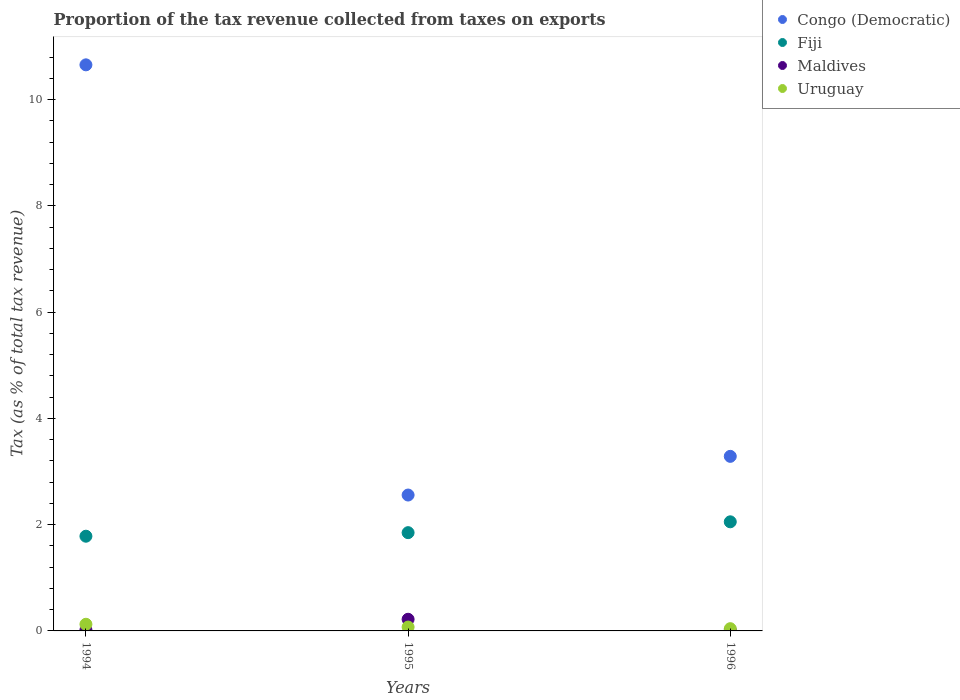How many different coloured dotlines are there?
Offer a very short reply. 4. What is the proportion of the tax revenue collected in Fiji in 1996?
Offer a terse response. 2.05. Across all years, what is the maximum proportion of the tax revenue collected in Maldives?
Offer a terse response. 0.22. Across all years, what is the minimum proportion of the tax revenue collected in Uruguay?
Keep it short and to the point. 0.04. What is the total proportion of the tax revenue collected in Maldives in the graph?
Provide a succinct answer. 0.25. What is the difference between the proportion of the tax revenue collected in Maldives in 1995 and that in 1996?
Provide a short and direct response. 0.21. What is the difference between the proportion of the tax revenue collected in Fiji in 1994 and the proportion of the tax revenue collected in Congo (Democratic) in 1996?
Your response must be concise. -1.5. What is the average proportion of the tax revenue collected in Uruguay per year?
Provide a succinct answer. 0.08. In the year 1995, what is the difference between the proportion of the tax revenue collected in Maldives and proportion of the tax revenue collected in Fiji?
Provide a succinct answer. -1.63. In how many years, is the proportion of the tax revenue collected in Fiji greater than 4.8 %?
Offer a very short reply. 0. What is the ratio of the proportion of the tax revenue collected in Congo (Democratic) in 1995 to that in 1996?
Ensure brevity in your answer.  0.78. Is the proportion of the tax revenue collected in Maldives in 1995 less than that in 1996?
Offer a very short reply. No. Is the difference between the proportion of the tax revenue collected in Maldives in 1995 and 1996 greater than the difference between the proportion of the tax revenue collected in Fiji in 1995 and 1996?
Your answer should be compact. Yes. What is the difference between the highest and the second highest proportion of the tax revenue collected in Congo (Democratic)?
Your answer should be very brief. 7.37. What is the difference between the highest and the lowest proportion of the tax revenue collected in Congo (Democratic)?
Give a very brief answer. 8.1. In how many years, is the proportion of the tax revenue collected in Fiji greater than the average proportion of the tax revenue collected in Fiji taken over all years?
Offer a very short reply. 1. Is it the case that in every year, the sum of the proportion of the tax revenue collected in Uruguay and proportion of the tax revenue collected in Fiji  is greater than the sum of proportion of the tax revenue collected in Congo (Democratic) and proportion of the tax revenue collected in Maldives?
Make the answer very short. No. Is the proportion of the tax revenue collected in Maldives strictly less than the proportion of the tax revenue collected in Uruguay over the years?
Your response must be concise. No. How many dotlines are there?
Your response must be concise. 4. Does the graph contain grids?
Offer a terse response. No. How many legend labels are there?
Provide a short and direct response. 4. What is the title of the graph?
Your answer should be compact. Proportion of the tax revenue collected from taxes on exports. Does "Albania" appear as one of the legend labels in the graph?
Offer a very short reply. No. What is the label or title of the Y-axis?
Your answer should be compact. Tax (as % of total tax revenue). What is the Tax (as % of total tax revenue) in Congo (Democratic) in 1994?
Ensure brevity in your answer.  10.65. What is the Tax (as % of total tax revenue) in Fiji in 1994?
Make the answer very short. 1.78. What is the Tax (as % of total tax revenue) of Maldives in 1994?
Your response must be concise. 0.02. What is the Tax (as % of total tax revenue) in Uruguay in 1994?
Your answer should be compact. 0.13. What is the Tax (as % of total tax revenue) of Congo (Democratic) in 1995?
Your answer should be compact. 2.56. What is the Tax (as % of total tax revenue) of Fiji in 1995?
Ensure brevity in your answer.  1.85. What is the Tax (as % of total tax revenue) of Maldives in 1995?
Give a very brief answer. 0.22. What is the Tax (as % of total tax revenue) in Uruguay in 1995?
Ensure brevity in your answer.  0.07. What is the Tax (as % of total tax revenue) in Congo (Democratic) in 1996?
Offer a terse response. 3.29. What is the Tax (as % of total tax revenue) in Fiji in 1996?
Your response must be concise. 2.05. What is the Tax (as % of total tax revenue) of Maldives in 1996?
Your response must be concise. 0.01. What is the Tax (as % of total tax revenue) of Uruguay in 1996?
Your response must be concise. 0.04. Across all years, what is the maximum Tax (as % of total tax revenue) in Congo (Democratic)?
Your answer should be very brief. 10.65. Across all years, what is the maximum Tax (as % of total tax revenue) of Fiji?
Your response must be concise. 2.05. Across all years, what is the maximum Tax (as % of total tax revenue) in Maldives?
Make the answer very short. 0.22. Across all years, what is the maximum Tax (as % of total tax revenue) of Uruguay?
Ensure brevity in your answer.  0.13. Across all years, what is the minimum Tax (as % of total tax revenue) in Congo (Democratic)?
Make the answer very short. 2.56. Across all years, what is the minimum Tax (as % of total tax revenue) in Fiji?
Keep it short and to the point. 1.78. Across all years, what is the minimum Tax (as % of total tax revenue) of Maldives?
Make the answer very short. 0.01. Across all years, what is the minimum Tax (as % of total tax revenue) in Uruguay?
Your answer should be very brief. 0.04. What is the total Tax (as % of total tax revenue) of Congo (Democratic) in the graph?
Make the answer very short. 16.5. What is the total Tax (as % of total tax revenue) in Fiji in the graph?
Give a very brief answer. 5.69. What is the total Tax (as % of total tax revenue) of Maldives in the graph?
Provide a short and direct response. 0.25. What is the total Tax (as % of total tax revenue) of Uruguay in the graph?
Offer a terse response. 0.24. What is the difference between the Tax (as % of total tax revenue) of Congo (Democratic) in 1994 and that in 1995?
Your answer should be compact. 8.1. What is the difference between the Tax (as % of total tax revenue) in Fiji in 1994 and that in 1995?
Your answer should be very brief. -0.07. What is the difference between the Tax (as % of total tax revenue) in Maldives in 1994 and that in 1995?
Offer a terse response. -0.2. What is the difference between the Tax (as % of total tax revenue) of Uruguay in 1994 and that in 1995?
Provide a succinct answer. 0.05. What is the difference between the Tax (as % of total tax revenue) of Congo (Democratic) in 1994 and that in 1996?
Make the answer very short. 7.37. What is the difference between the Tax (as % of total tax revenue) of Fiji in 1994 and that in 1996?
Make the answer very short. -0.27. What is the difference between the Tax (as % of total tax revenue) of Maldives in 1994 and that in 1996?
Your answer should be very brief. 0. What is the difference between the Tax (as % of total tax revenue) in Uruguay in 1994 and that in 1996?
Your answer should be very brief. 0.08. What is the difference between the Tax (as % of total tax revenue) in Congo (Democratic) in 1995 and that in 1996?
Make the answer very short. -0.73. What is the difference between the Tax (as % of total tax revenue) in Fiji in 1995 and that in 1996?
Your answer should be compact. -0.2. What is the difference between the Tax (as % of total tax revenue) in Maldives in 1995 and that in 1996?
Offer a very short reply. 0.21. What is the difference between the Tax (as % of total tax revenue) of Uruguay in 1995 and that in 1996?
Offer a very short reply. 0.03. What is the difference between the Tax (as % of total tax revenue) of Congo (Democratic) in 1994 and the Tax (as % of total tax revenue) of Fiji in 1995?
Offer a very short reply. 8.8. What is the difference between the Tax (as % of total tax revenue) of Congo (Democratic) in 1994 and the Tax (as % of total tax revenue) of Maldives in 1995?
Provide a short and direct response. 10.44. What is the difference between the Tax (as % of total tax revenue) of Congo (Democratic) in 1994 and the Tax (as % of total tax revenue) of Uruguay in 1995?
Your answer should be very brief. 10.58. What is the difference between the Tax (as % of total tax revenue) in Fiji in 1994 and the Tax (as % of total tax revenue) in Maldives in 1995?
Ensure brevity in your answer.  1.56. What is the difference between the Tax (as % of total tax revenue) of Fiji in 1994 and the Tax (as % of total tax revenue) of Uruguay in 1995?
Make the answer very short. 1.71. What is the difference between the Tax (as % of total tax revenue) of Maldives in 1994 and the Tax (as % of total tax revenue) of Uruguay in 1995?
Make the answer very short. -0.05. What is the difference between the Tax (as % of total tax revenue) of Congo (Democratic) in 1994 and the Tax (as % of total tax revenue) of Fiji in 1996?
Make the answer very short. 8.6. What is the difference between the Tax (as % of total tax revenue) of Congo (Democratic) in 1994 and the Tax (as % of total tax revenue) of Maldives in 1996?
Offer a very short reply. 10.64. What is the difference between the Tax (as % of total tax revenue) in Congo (Democratic) in 1994 and the Tax (as % of total tax revenue) in Uruguay in 1996?
Keep it short and to the point. 10.61. What is the difference between the Tax (as % of total tax revenue) in Fiji in 1994 and the Tax (as % of total tax revenue) in Maldives in 1996?
Your answer should be very brief. 1.77. What is the difference between the Tax (as % of total tax revenue) of Fiji in 1994 and the Tax (as % of total tax revenue) of Uruguay in 1996?
Make the answer very short. 1.74. What is the difference between the Tax (as % of total tax revenue) of Maldives in 1994 and the Tax (as % of total tax revenue) of Uruguay in 1996?
Offer a terse response. -0.02. What is the difference between the Tax (as % of total tax revenue) of Congo (Democratic) in 1995 and the Tax (as % of total tax revenue) of Fiji in 1996?
Give a very brief answer. 0.5. What is the difference between the Tax (as % of total tax revenue) of Congo (Democratic) in 1995 and the Tax (as % of total tax revenue) of Maldives in 1996?
Your answer should be compact. 2.54. What is the difference between the Tax (as % of total tax revenue) of Congo (Democratic) in 1995 and the Tax (as % of total tax revenue) of Uruguay in 1996?
Provide a short and direct response. 2.52. What is the difference between the Tax (as % of total tax revenue) of Fiji in 1995 and the Tax (as % of total tax revenue) of Maldives in 1996?
Your answer should be very brief. 1.84. What is the difference between the Tax (as % of total tax revenue) in Fiji in 1995 and the Tax (as % of total tax revenue) in Uruguay in 1996?
Your response must be concise. 1.81. What is the difference between the Tax (as % of total tax revenue) in Maldives in 1995 and the Tax (as % of total tax revenue) in Uruguay in 1996?
Provide a succinct answer. 0.18. What is the average Tax (as % of total tax revenue) of Congo (Democratic) per year?
Provide a short and direct response. 5.5. What is the average Tax (as % of total tax revenue) in Fiji per year?
Provide a short and direct response. 1.9. What is the average Tax (as % of total tax revenue) in Maldives per year?
Keep it short and to the point. 0.08. In the year 1994, what is the difference between the Tax (as % of total tax revenue) of Congo (Democratic) and Tax (as % of total tax revenue) of Fiji?
Provide a succinct answer. 8.87. In the year 1994, what is the difference between the Tax (as % of total tax revenue) in Congo (Democratic) and Tax (as % of total tax revenue) in Maldives?
Ensure brevity in your answer.  10.64. In the year 1994, what is the difference between the Tax (as % of total tax revenue) in Congo (Democratic) and Tax (as % of total tax revenue) in Uruguay?
Offer a very short reply. 10.53. In the year 1994, what is the difference between the Tax (as % of total tax revenue) of Fiji and Tax (as % of total tax revenue) of Maldives?
Provide a succinct answer. 1.76. In the year 1994, what is the difference between the Tax (as % of total tax revenue) in Fiji and Tax (as % of total tax revenue) in Uruguay?
Provide a succinct answer. 1.66. In the year 1994, what is the difference between the Tax (as % of total tax revenue) in Maldives and Tax (as % of total tax revenue) in Uruguay?
Your response must be concise. -0.11. In the year 1995, what is the difference between the Tax (as % of total tax revenue) in Congo (Democratic) and Tax (as % of total tax revenue) in Fiji?
Give a very brief answer. 0.71. In the year 1995, what is the difference between the Tax (as % of total tax revenue) of Congo (Democratic) and Tax (as % of total tax revenue) of Maldives?
Ensure brevity in your answer.  2.34. In the year 1995, what is the difference between the Tax (as % of total tax revenue) of Congo (Democratic) and Tax (as % of total tax revenue) of Uruguay?
Make the answer very short. 2.48. In the year 1995, what is the difference between the Tax (as % of total tax revenue) in Fiji and Tax (as % of total tax revenue) in Maldives?
Provide a short and direct response. 1.63. In the year 1995, what is the difference between the Tax (as % of total tax revenue) in Fiji and Tax (as % of total tax revenue) in Uruguay?
Your answer should be very brief. 1.78. In the year 1995, what is the difference between the Tax (as % of total tax revenue) of Maldives and Tax (as % of total tax revenue) of Uruguay?
Offer a very short reply. 0.15. In the year 1996, what is the difference between the Tax (as % of total tax revenue) of Congo (Democratic) and Tax (as % of total tax revenue) of Fiji?
Provide a succinct answer. 1.23. In the year 1996, what is the difference between the Tax (as % of total tax revenue) of Congo (Democratic) and Tax (as % of total tax revenue) of Maldives?
Keep it short and to the point. 3.27. In the year 1996, what is the difference between the Tax (as % of total tax revenue) in Congo (Democratic) and Tax (as % of total tax revenue) in Uruguay?
Your answer should be compact. 3.24. In the year 1996, what is the difference between the Tax (as % of total tax revenue) of Fiji and Tax (as % of total tax revenue) of Maldives?
Offer a very short reply. 2.04. In the year 1996, what is the difference between the Tax (as % of total tax revenue) of Fiji and Tax (as % of total tax revenue) of Uruguay?
Keep it short and to the point. 2.01. In the year 1996, what is the difference between the Tax (as % of total tax revenue) of Maldives and Tax (as % of total tax revenue) of Uruguay?
Ensure brevity in your answer.  -0.03. What is the ratio of the Tax (as % of total tax revenue) in Congo (Democratic) in 1994 to that in 1995?
Ensure brevity in your answer.  4.17. What is the ratio of the Tax (as % of total tax revenue) in Fiji in 1994 to that in 1995?
Ensure brevity in your answer.  0.96. What is the ratio of the Tax (as % of total tax revenue) in Maldives in 1994 to that in 1995?
Provide a succinct answer. 0.09. What is the ratio of the Tax (as % of total tax revenue) in Uruguay in 1994 to that in 1995?
Offer a very short reply. 1.73. What is the ratio of the Tax (as % of total tax revenue) of Congo (Democratic) in 1994 to that in 1996?
Make the answer very short. 3.24. What is the ratio of the Tax (as % of total tax revenue) of Fiji in 1994 to that in 1996?
Make the answer very short. 0.87. What is the ratio of the Tax (as % of total tax revenue) in Maldives in 1994 to that in 1996?
Provide a succinct answer. 1.33. What is the ratio of the Tax (as % of total tax revenue) in Uruguay in 1994 to that in 1996?
Give a very brief answer. 2.96. What is the ratio of the Tax (as % of total tax revenue) of Congo (Democratic) in 1995 to that in 1996?
Your answer should be compact. 0.78. What is the ratio of the Tax (as % of total tax revenue) of Fiji in 1995 to that in 1996?
Give a very brief answer. 0.9. What is the ratio of the Tax (as % of total tax revenue) in Maldives in 1995 to that in 1996?
Your answer should be very brief. 15.64. What is the ratio of the Tax (as % of total tax revenue) in Uruguay in 1995 to that in 1996?
Ensure brevity in your answer.  1.72. What is the difference between the highest and the second highest Tax (as % of total tax revenue) of Congo (Democratic)?
Keep it short and to the point. 7.37. What is the difference between the highest and the second highest Tax (as % of total tax revenue) in Fiji?
Ensure brevity in your answer.  0.2. What is the difference between the highest and the second highest Tax (as % of total tax revenue) in Maldives?
Make the answer very short. 0.2. What is the difference between the highest and the second highest Tax (as % of total tax revenue) of Uruguay?
Your answer should be very brief. 0.05. What is the difference between the highest and the lowest Tax (as % of total tax revenue) in Congo (Democratic)?
Give a very brief answer. 8.1. What is the difference between the highest and the lowest Tax (as % of total tax revenue) in Fiji?
Your response must be concise. 0.27. What is the difference between the highest and the lowest Tax (as % of total tax revenue) in Maldives?
Keep it short and to the point. 0.21. What is the difference between the highest and the lowest Tax (as % of total tax revenue) in Uruguay?
Your answer should be compact. 0.08. 